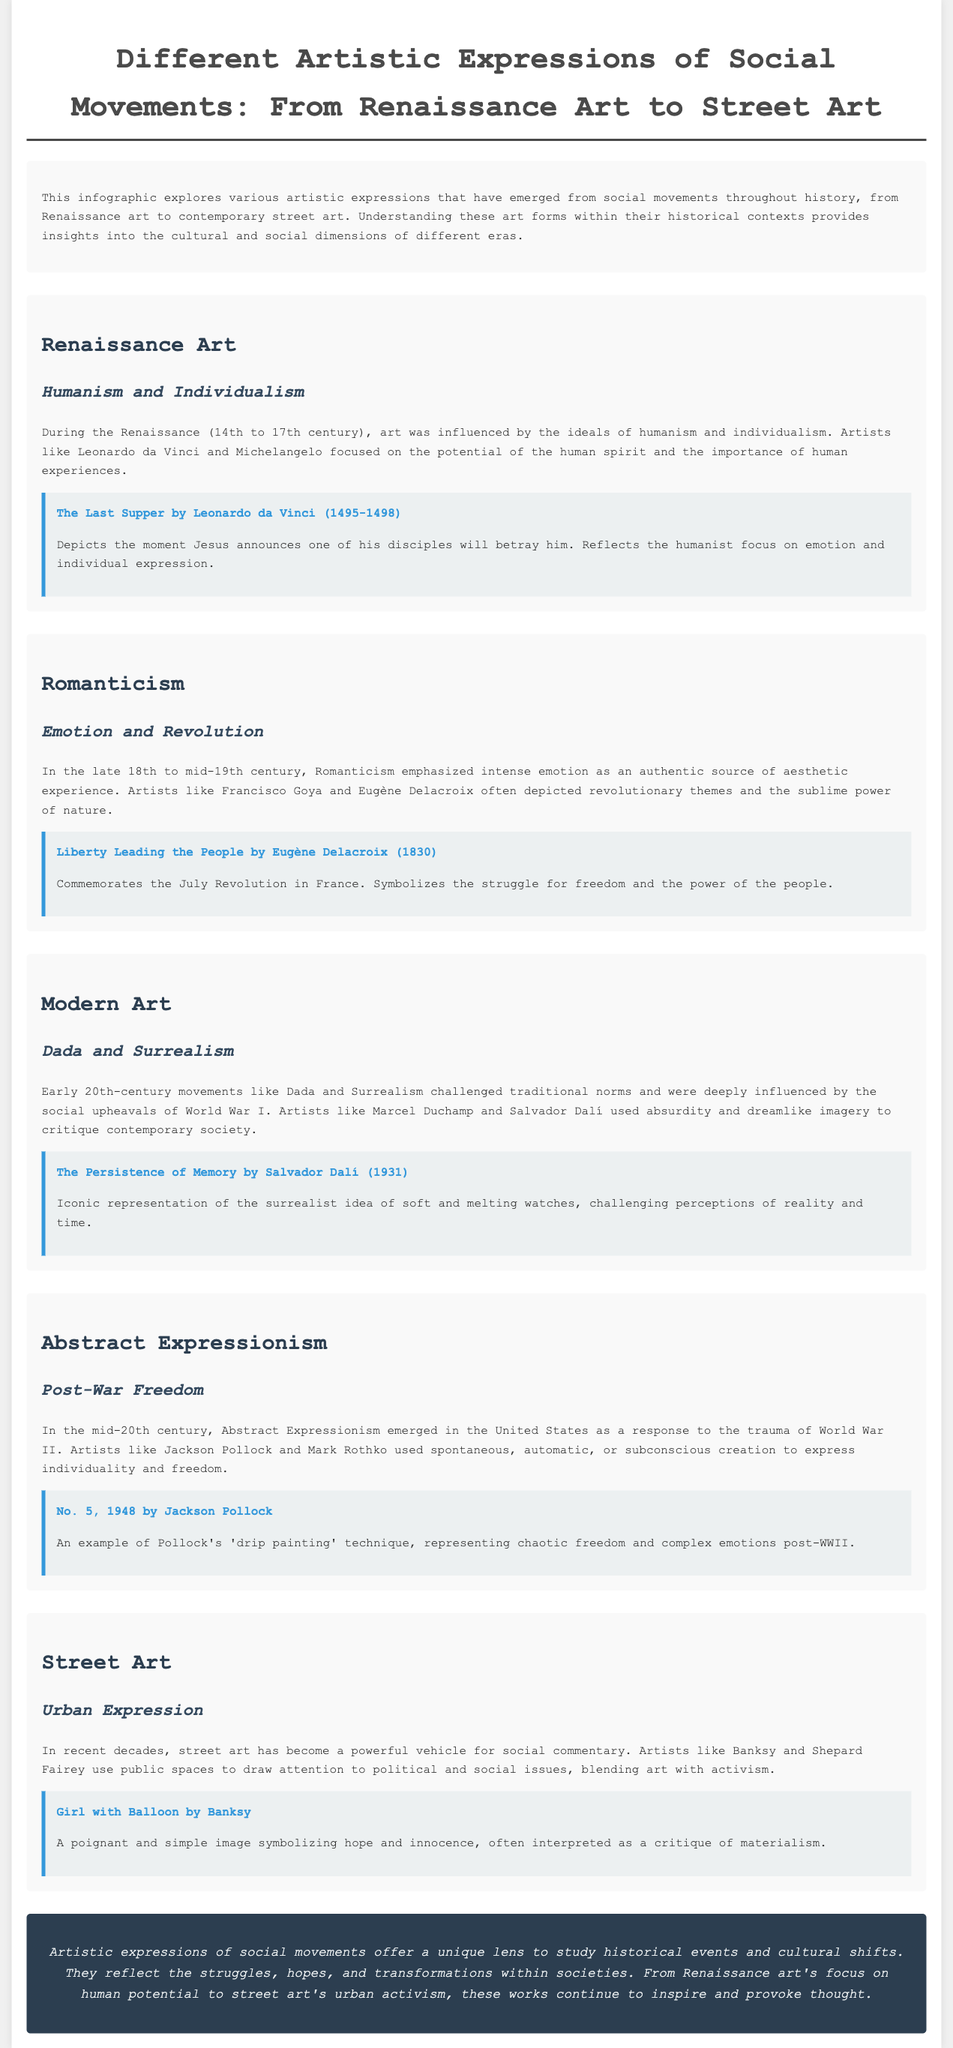What is the title of the infographic? The title of the infographic is clearly stated at the beginning, which is “Different Artistic Expressions of Social Movements: From Renaissance Art to Street Art.”
Answer: Different Artistic Expressions of Social Movements: From Renaissance Art to Street Art Who painted "The Last Supper"? "The Last Supper" is a notable artwork discussed within the Renaissance section, attributed to Leonardo da Vinci.
Answer: Leonardo da Vinci What year was "Liberty Leading the People" created? In the Romanticism section, "Liberty Leading the People" is specifically noted as being completed in the year 1830.
Answer: 1830 What art movement is characterized by Dada and Surrealism? The Modern Art section highlights Dada and Surrealism as significant movements during the early 20th century.
Answer: Modern Art What does street art primarily blend with? The infographic states that street art blends with activism, focusing on political and social issues.
Answer: Activism What emotional theme did Romanticism emphasize? The infographics specify that Romanticism emphasized intense emotion as an authentic source of aesthetic experience.
Answer: Emotion How did Abstract Expressionism respond to social events? The section on Abstract Expressionism indicates that it emerged in response to the trauma of World War II.
Answer: Trauma of World War II Which artist created "Girl with Balloon"? The section on Street Art attributes "Girl with Balloon" to Banksy, a well-known street artist.
Answer: Banksy 